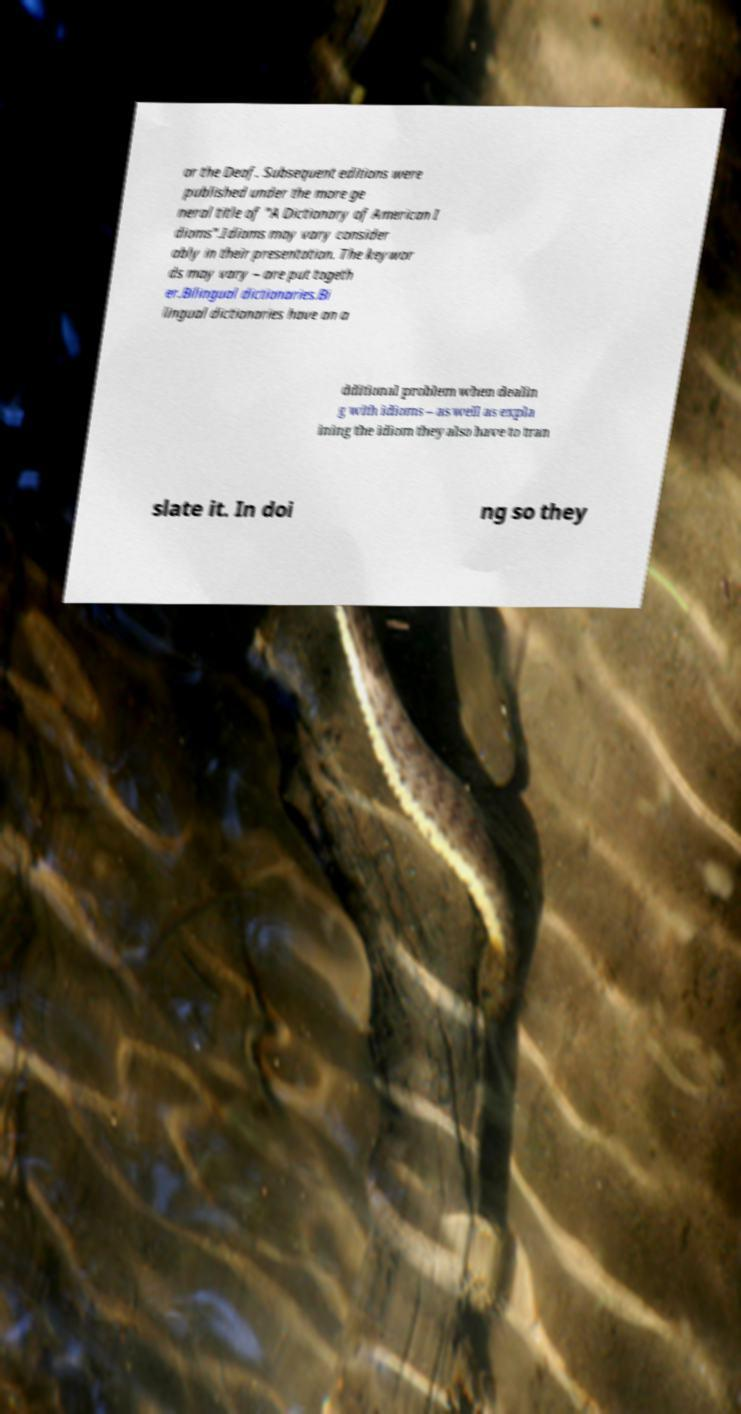Could you assist in decoding the text presented in this image and type it out clearly? or the Deaf. Subsequent editions were published under the more ge neral title of "A Dictionary of American I dioms".Idioms may vary consider ably in their presentation. The keywor ds may vary – are put togeth er.Bilingual dictionaries.Bi lingual dictionaries have an a dditional problem when dealin g with idioms – as well as expla ining the idiom they also have to tran slate it. In doi ng so they 